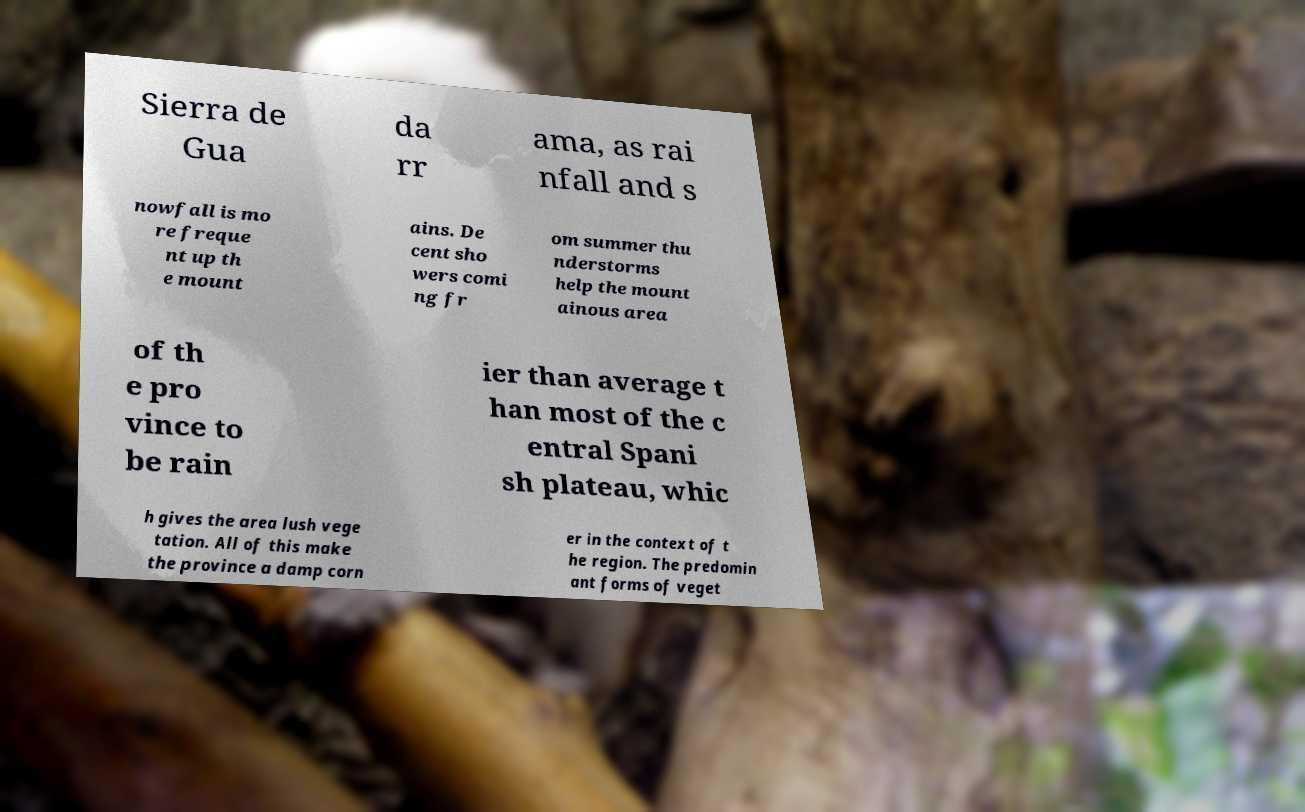Please identify and transcribe the text found in this image. Sierra de Gua da rr ama, as rai nfall and s nowfall is mo re freque nt up th e mount ains. De cent sho wers comi ng fr om summer thu nderstorms help the mount ainous area of th e pro vince to be rain ier than average t han most of the c entral Spani sh plateau, whic h gives the area lush vege tation. All of this make the province a damp corn er in the context of t he region. The predomin ant forms of veget 